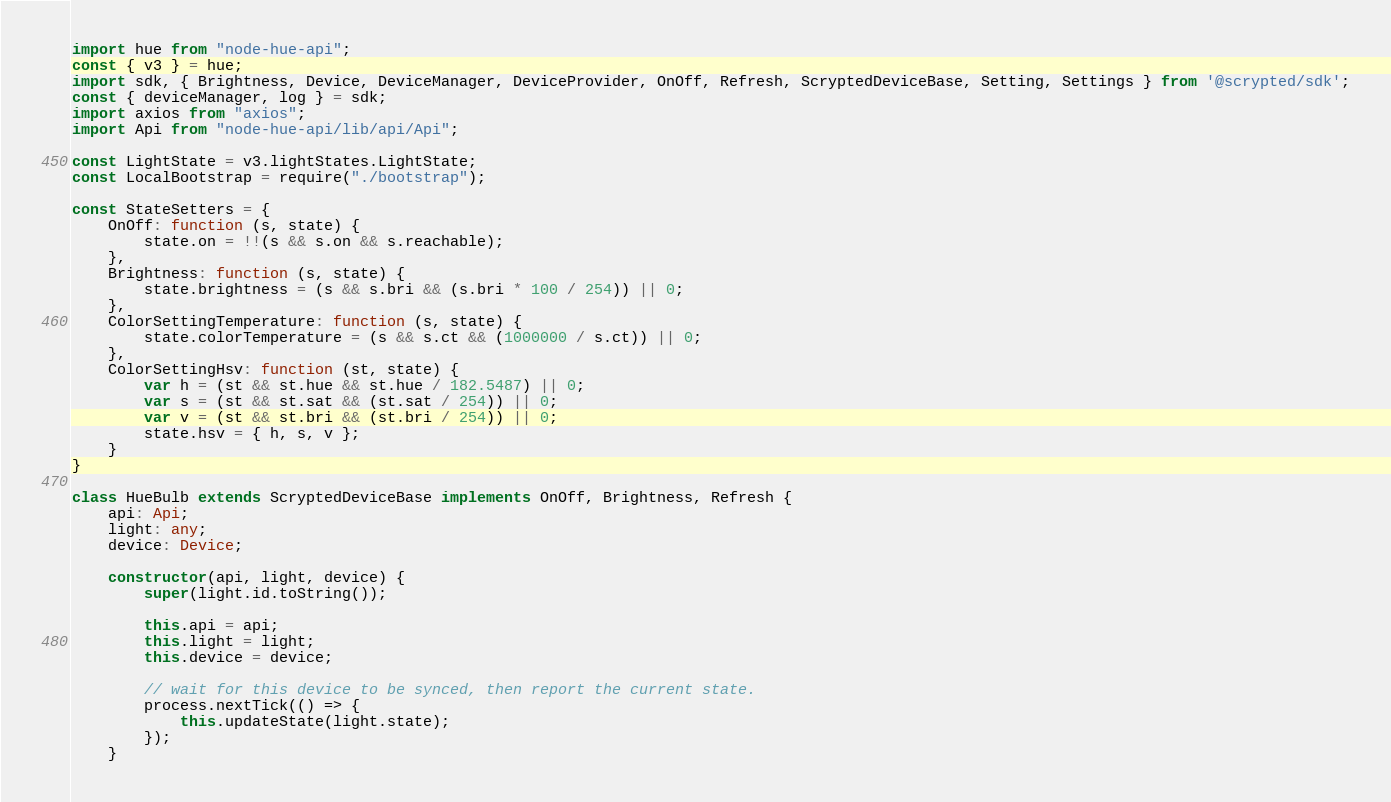Convert code to text. <code><loc_0><loc_0><loc_500><loc_500><_TypeScript_>import hue from "node-hue-api";
const { v3 } = hue;
import sdk, { Brightness, Device, DeviceManager, DeviceProvider, OnOff, Refresh, ScryptedDeviceBase, Setting, Settings } from '@scrypted/sdk';
const { deviceManager, log } = sdk;
import axios from "axios";
import Api from "node-hue-api/lib/api/Api";

const LightState = v3.lightStates.LightState;
const LocalBootstrap = require("./bootstrap");

const StateSetters = {
    OnOff: function (s, state) {
        state.on = !!(s && s.on && s.reachable);
    },
    Brightness: function (s, state) {
        state.brightness = (s && s.bri && (s.bri * 100 / 254)) || 0;
    },
    ColorSettingTemperature: function (s, state) {
        state.colorTemperature = (s && s.ct && (1000000 / s.ct)) || 0;
    },
    ColorSettingHsv: function (st, state) {
        var h = (st && st.hue && st.hue / 182.5487) || 0;
        var s = (st && st.sat && (st.sat / 254)) || 0;
        var v = (st && st.bri && (st.bri / 254)) || 0;
        state.hsv = { h, s, v };
    }
}

class HueBulb extends ScryptedDeviceBase implements OnOff, Brightness, Refresh {
    api: Api;
    light: any;
    device: Device;

    constructor(api, light, device) {
        super(light.id.toString());

        this.api = api;
        this.light = light;
        this.device = device;

        // wait for this device to be synced, then report the current state.
        process.nextTick(() => {
            this.updateState(light.state);
        });
    }
</code> 